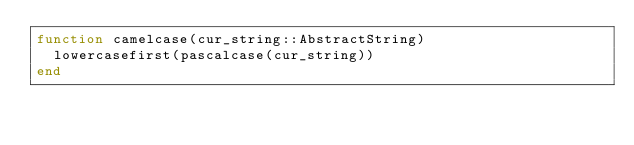<code> <loc_0><loc_0><loc_500><loc_500><_Julia_>function camelcase(cur_string::AbstractString)
  lowercasefirst(pascalcase(cur_string))
end
</code> 